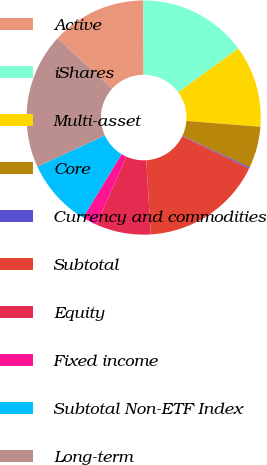Convert chart to OTSL. <chart><loc_0><loc_0><loc_500><loc_500><pie_chart><fcel>Active<fcel>iShares<fcel>Multi-asset<fcel>Core<fcel>Currency and commodities<fcel>Subtotal<fcel>Equity<fcel>Fixed income<fcel>Subtotal Non-ETF Index<fcel>Long-term<nl><fcel>13.15%<fcel>15.0%<fcel>11.3%<fcel>5.74%<fcel>0.19%<fcel>16.85%<fcel>7.59%<fcel>2.04%<fcel>9.44%<fcel>18.7%<nl></chart> 